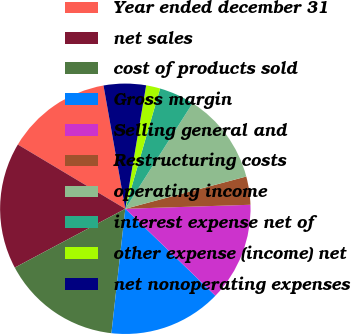Convert chart to OTSL. <chart><loc_0><loc_0><loc_500><loc_500><pie_chart><fcel>Year ended december 31<fcel>net sales<fcel>cost of products sold<fcel>Gross margin<fcel>Selling general and<fcel>Restructuring costs<fcel>operating income<fcel>interest expense net of<fcel>other expense (income) net<fcel>net nonoperating expenses<nl><fcel>13.64%<fcel>16.36%<fcel>15.45%<fcel>14.55%<fcel>12.73%<fcel>3.64%<fcel>11.82%<fcel>4.55%<fcel>1.82%<fcel>5.45%<nl></chart> 